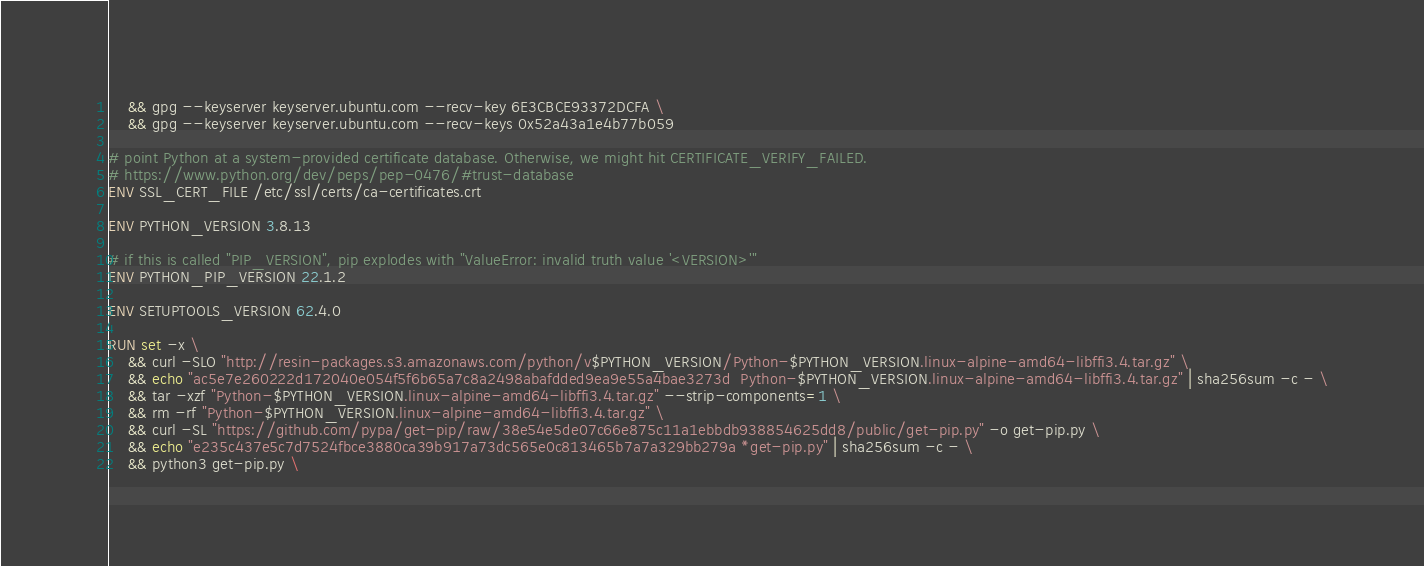<code> <loc_0><loc_0><loc_500><loc_500><_Dockerfile_>	&& gpg --keyserver keyserver.ubuntu.com --recv-key 6E3CBCE93372DCFA \
	&& gpg --keyserver keyserver.ubuntu.com --recv-keys 0x52a43a1e4b77b059

# point Python at a system-provided certificate database. Otherwise, we might hit CERTIFICATE_VERIFY_FAILED.
# https://www.python.org/dev/peps/pep-0476/#trust-database
ENV SSL_CERT_FILE /etc/ssl/certs/ca-certificates.crt

ENV PYTHON_VERSION 3.8.13

# if this is called "PIP_VERSION", pip explodes with "ValueError: invalid truth value '<VERSION>'"
ENV PYTHON_PIP_VERSION 22.1.2

ENV SETUPTOOLS_VERSION 62.4.0

RUN set -x \
	&& curl -SLO "http://resin-packages.s3.amazonaws.com/python/v$PYTHON_VERSION/Python-$PYTHON_VERSION.linux-alpine-amd64-libffi3.4.tar.gz" \
	&& echo "ac5e7e260222d172040e054f5f6b65a7c8a2498abafdded9ea9e55a4bae3273d  Python-$PYTHON_VERSION.linux-alpine-amd64-libffi3.4.tar.gz" | sha256sum -c - \
	&& tar -xzf "Python-$PYTHON_VERSION.linux-alpine-amd64-libffi3.4.tar.gz" --strip-components=1 \
	&& rm -rf "Python-$PYTHON_VERSION.linux-alpine-amd64-libffi3.4.tar.gz" \
	&& curl -SL "https://github.com/pypa/get-pip/raw/38e54e5de07c66e875c11a1ebbdb938854625dd8/public/get-pip.py" -o get-pip.py \
    && echo "e235c437e5c7d7524fbce3880ca39b917a73dc565e0c813465b7a7a329bb279a *get-pip.py" | sha256sum -c - \
    && python3 get-pip.py \</code> 